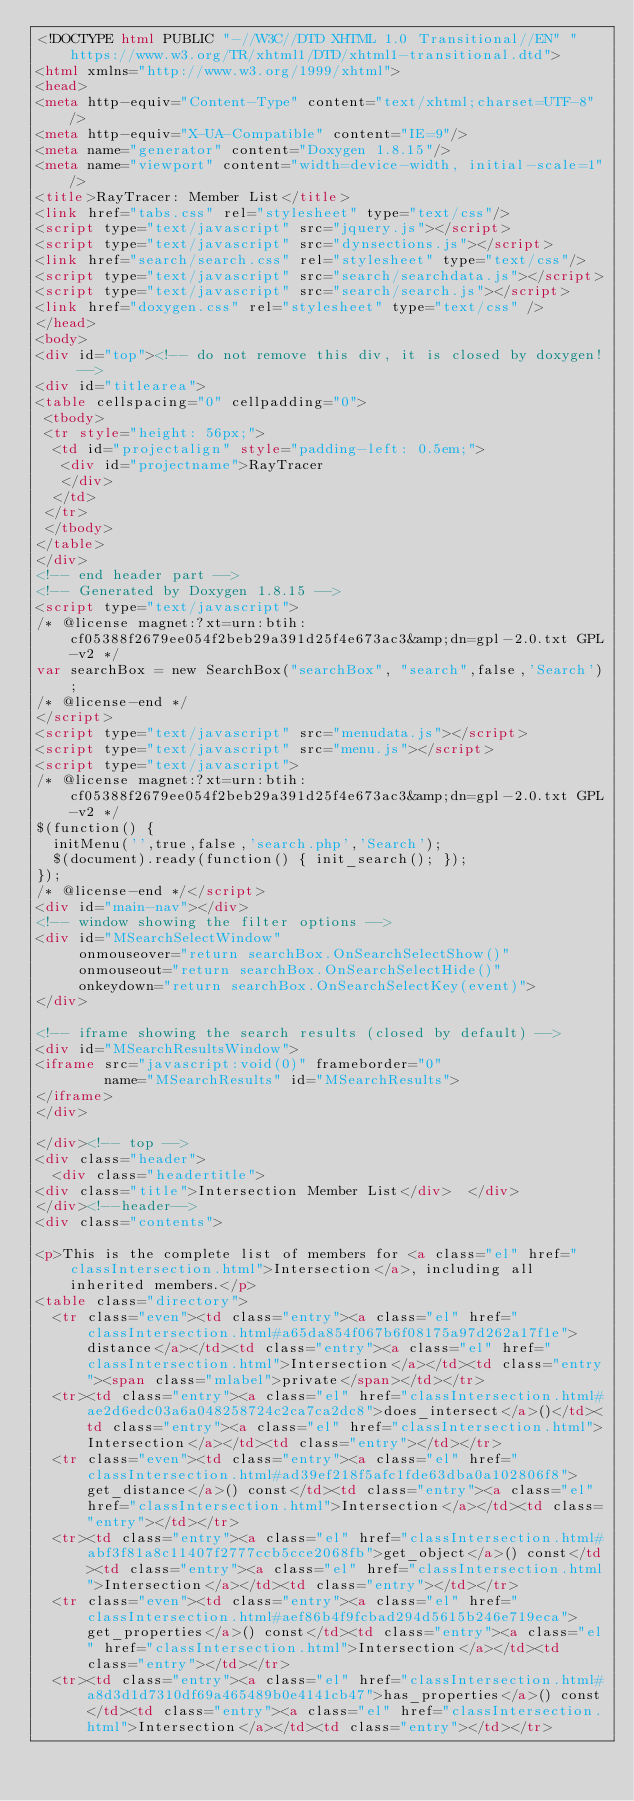Convert code to text. <code><loc_0><loc_0><loc_500><loc_500><_HTML_><!DOCTYPE html PUBLIC "-//W3C//DTD XHTML 1.0 Transitional//EN" "https://www.w3.org/TR/xhtml1/DTD/xhtml1-transitional.dtd">
<html xmlns="http://www.w3.org/1999/xhtml">
<head>
<meta http-equiv="Content-Type" content="text/xhtml;charset=UTF-8"/>
<meta http-equiv="X-UA-Compatible" content="IE=9"/>
<meta name="generator" content="Doxygen 1.8.15"/>
<meta name="viewport" content="width=device-width, initial-scale=1"/>
<title>RayTracer: Member List</title>
<link href="tabs.css" rel="stylesheet" type="text/css"/>
<script type="text/javascript" src="jquery.js"></script>
<script type="text/javascript" src="dynsections.js"></script>
<link href="search/search.css" rel="stylesheet" type="text/css"/>
<script type="text/javascript" src="search/searchdata.js"></script>
<script type="text/javascript" src="search/search.js"></script>
<link href="doxygen.css" rel="stylesheet" type="text/css" />
</head>
<body>
<div id="top"><!-- do not remove this div, it is closed by doxygen! -->
<div id="titlearea">
<table cellspacing="0" cellpadding="0">
 <tbody>
 <tr style="height: 56px;">
  <td id="projectalign" style="padding-left: 0.5em;">
   <div id="projectname">RayTracer
   </div>
  </td>
 </tr>
 </tbody>
</table>
</div>
<!-- end header part -->
<!-- Generated by Doxygen 1.8.15 -->
<script type="text/javascript">
/* @license magnet:?xt=urn:btih:cf05388f2679ee054f2beb29a391d25f4e673ac3&amp;dn=gpl-2.0.txt GPL-v2 */
var searchBox = new SearchBox("searchBox", "search",false,'Search');
/* @license-end */
</script>
<script type="text/javascript" src="menudata.js"></script>
<script type="text/javascript" src="menu.js"></script>
<script type="text/javascript">
/* @license magnet:?xt=urn:btih:cf05388f2679ee054f2beb29a391d25f4e673ac3&amp;dn=gpl-2.0.txt GPL-v2 */
$(function() {
  initMenu('',true,false,'search.php','Search');
  $(document).ready(function() { init_search(); });
});
/* @license-end */</script>
<div id="main-nav"></div>
<!-- window showing the filter options -->
<div id="MSearchSelectWindow"
     onmouseover="return searchBox.OnSearchSelectShow()"
     onmouseout="return searchBox.OnSearchSelectHide()"
     onkeydown="return searchBox.OnSearchSelectKey(event)">
</div>

<!-- iframe showing the search results (closed by default) -->
<div id="MSearchResultsWindow">
<iframe src="javascript:void(0)" frameborder="0" 
        name="MSearchResults" id="MSearchResults">
</iframe>
</div>

</div><!-- top -->
<div class="header">
  <div class="headertitle">
<div class="title">Intersection Member List</div>  </div>
</div><!--header-->
<div class="contents">

<p>This is the complete list of members for <a class="el" href="classIntersection.html">Intersection</a>, including all inherited members.</p>
<table class="directory">
  <tr class="even"><td class="entry"><a class="el" href="classIntersection.html#a65da854f067b6f08175a97d262a17f1e">distance</a></td><td class="entry"><a class="el" href="classIntersection.html">Intersection</a></td><td class="entry"><span class="mlabel">private</span></td></tr>
  <tr><td class="entry"><a class="el" href="classIntersection.html#ae2d6edc03a6a048258724c2ca7ca2dc8">does_intersect</a>()</td><td class="entry"><a class="el" href="classIntersection.html">Intersection</a></td><td class="entry"></td></tr>
  <tr class="even"><td class="entry"><a class="el" href="classIntersection.html#ad39ef218f5afc1fde63dba0a102806f8">get_distance</a>() const</td><td class="entry"><a class="el" href="classIntersection.html">Intersection</a></td><td class="entry"></td></tr>
  <tr><td class="entry"><a class="el" href="classIntersection.html#abf3f81a8c11407f2777ccb5cce2068fb">get_object</a>() const</td><td class="entry"><a class="el" href="classIntersection.html">Intersection</a></td><td class="entry"></td></tr>
  <tr class="even"><td class="entry"><a class="el" href="classIntersection.html#aef86b4f9fcbad294d5615b246e719eca">get_properties</a>() const</td><td class="entry"><a class="el" href="classIntersection.html">Intersection</a></td><td class="entry"></td></tr>
  <tr><td class="entry"><a class="el" href="classIntersection.html#a8d3d1d7310df69a465489b0e4141cb47">has_properties</a>() const</td><td class="entry"><a class="el" href="classIntersection.html">Intersection</a></td><td class="entry"></td></tr></code> 